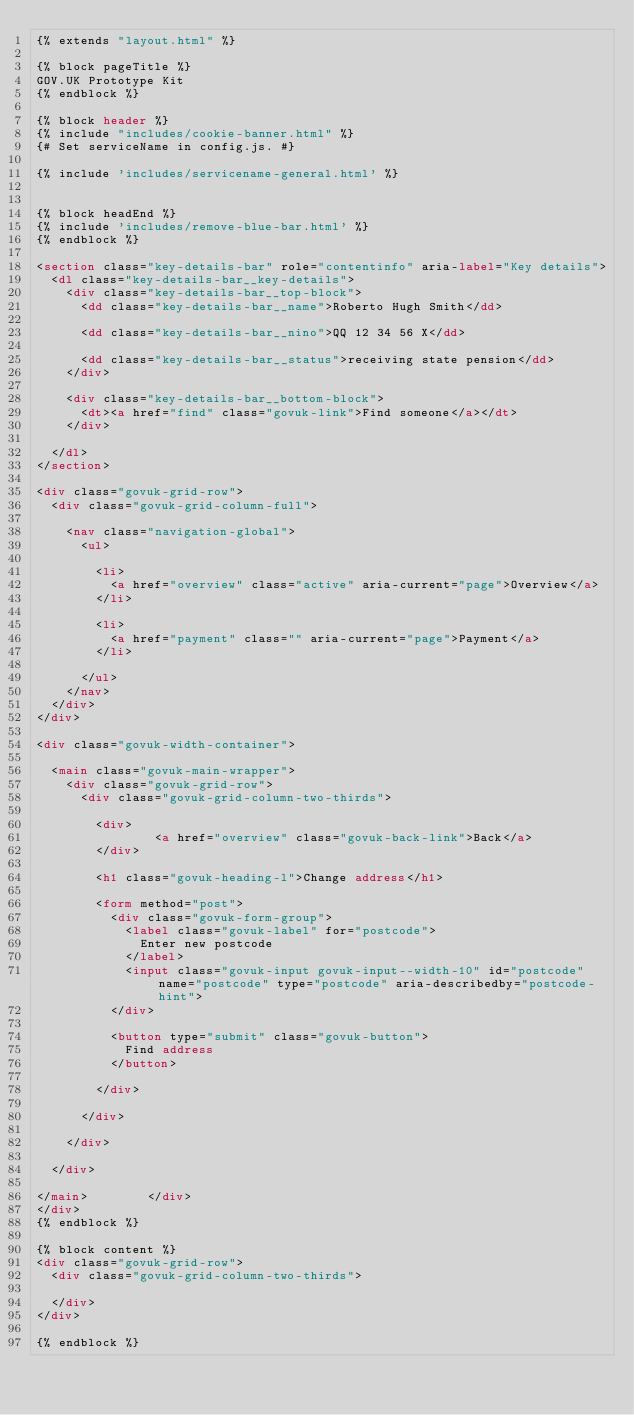<code> <loc_0><loc_0><loc_500><loc_500><_HTML_>{% extends "layout.html" %}

{% block pageTitle %}
GOV.UK Prototype Kit
{% endblock %}

{% block header %}
{% include "includes/cookie-banner.html" %}
{# Set serviceName in config.js. #}

{% include 'includes/servicename-general.html' %}


{% block headEnd %}
{% include 'includes/remove-blue-bar.html' %}
{% endblock %}

<section class="key-details-bar" role="contentinfo" aria-label="Key details">
  <dl class="key-details-bar__key-details">
    <div class="key-details-bar__top-block">
      <dd class="key-details-bar__name">Roberto Hugh Smith</dd>

      <dd class="key-details-bar__nino">QQ 12 34 56 X</dd>

      <dd class="key-details-bar__status">receiving state pension</dd>
    </div>

    <div class="key-details-bar__bottom-block">
      <dt><a href="find" class="govuk-link">Find someone</a></dt>
    </div>

  </dl>
</section>

<div class="govuk-grid-row">
  <div class="govuk-grid-column-full">

    <nav class="navigation-global">
      <ul>

        <li>
          <a href="overview" class="active" aria-current="page">Overview</a>
        </li>

        <li>
          <a href="payment" class="" aria-current="page">Payment</a>
        </li>

      </ul>
    </nav>
  </div>
</div>

<div class="govuk-width-container">

  <main class="govuk-main-wrapper">
    <div class="govuk-grid-row">
      <div class="govuk-grid-column-two-thirds">

        <div>
                <a href="overview" class="govuk-back-link">Back</a>
        </div>

        <h1 class="govuk-heading-l">Change address</h1>

        <form method="post">
          <div class="govuk-form-group">
            <label class="govuk-label" for="postcode">
              Enter new postcode
            </label>
            <input class="govuk-input govuk-input--width-10" id="postcode" name="postcode" type="postcode" aria-describedby="postcode-hint">
          </div>

          <button type="submit" class="govuk-button">
            Find address
          </button>

        </div>

      </div>

    </div>

  </div>

</main>        </div>
</div>
{% endblock %}

{% block content %}
<div class="govuk-grid-row">
  <div class="govuk-grid-column-two-thirds">

  </div>
</div>

{% endblock %}
</code> 